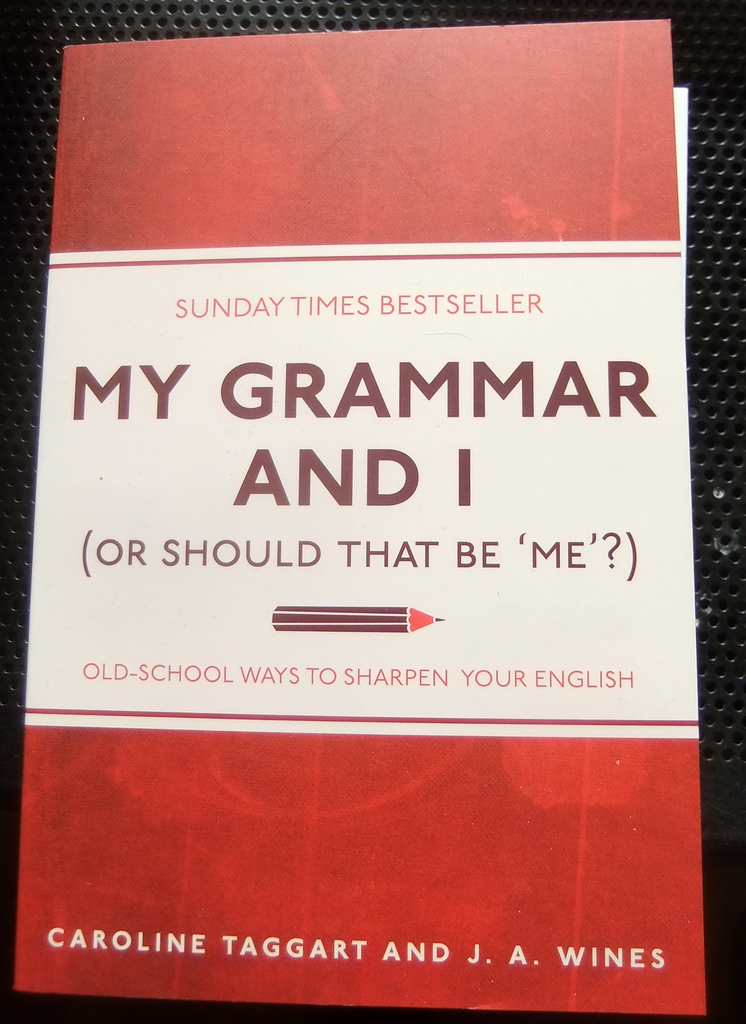What are the primary themes addressed in this book according to its cover? Based on the cover of 'My Grammar and I (Or Should That Be 'Me'?)', the main theme revolves around traditional grammar rules. The subtitle 'Old-School Ways to Sharpen Your English' along with the title itself suggests a focus on addressing common grammatical dilemmas and offering guidance on correct English usage and clarity in communication. 